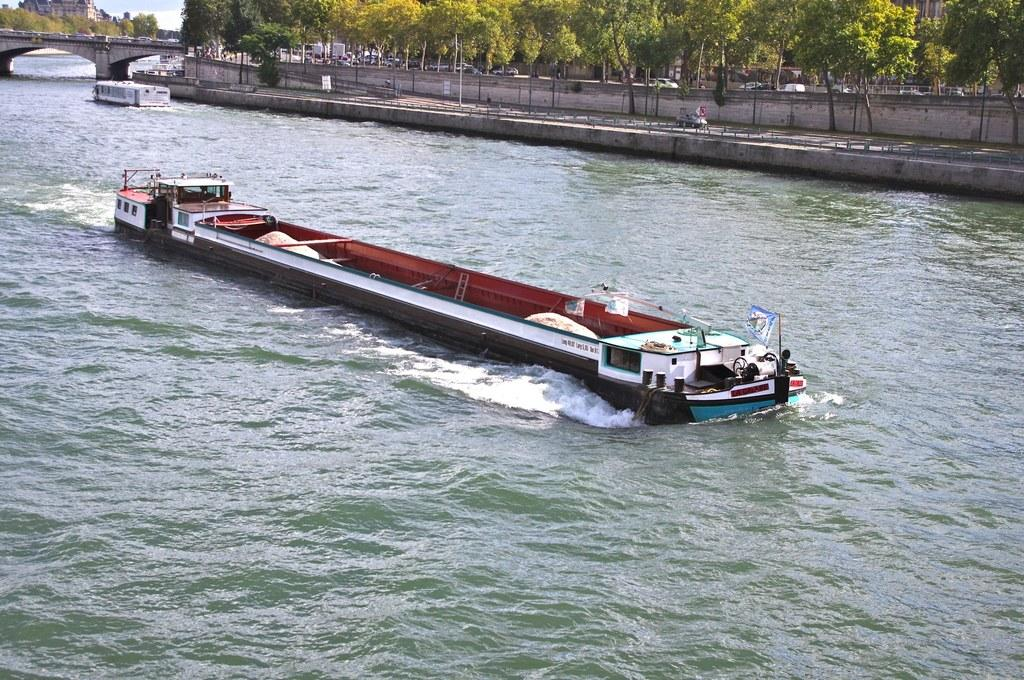What is located in the middle of the image? There is a board in the middle of the image. What can be seen in the background of the image? There are trees and vehicles in the background of the image. What is on the left side of the image? There is a bridge on the left side of the image. Can you describe the water visible in the image? The water is visible in the image, but its specific characteristics are not mentioned in the facts. How many geese are swimming in the water in the image? There is no mention of geese in the image, so it is impossible to determine their presence or number. What advice does the grandfather give to the person in the image? There is no mention of a grandfather or any person in the image, so it is impossible to determine any advice given. 